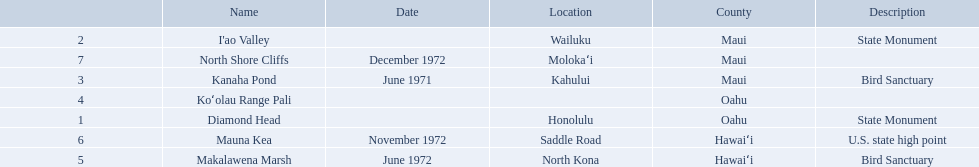What are the national natural landmarks in hawaii? Diamond Head, I'ao Valley, Kanaha Pond, Koʻolau Range Pali, Makalawena Marsh, Mauna Kea, North Shore Cliffs. Which of theses are in hawa'i county? Makalawena Marsh, Mauna Kea. Of these which has a bird sanctuary? Makalawena Marsh. 